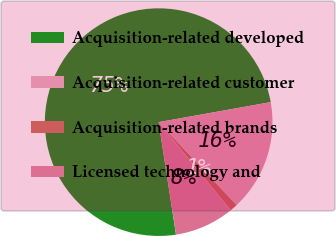Convert chart to OTSL. <chart><loc_0><loc_0><loc_500><loc_500><pie_chart><fcel>Acquisition-related developed<fcel>Acquisition-related customer<fcel>Acquisition-related brands<fcel>Licensed technology and<nl><fcel>74.62%<fcel>15.81%<fcel>1.11%<fcel>8.46%<nl></chart> 